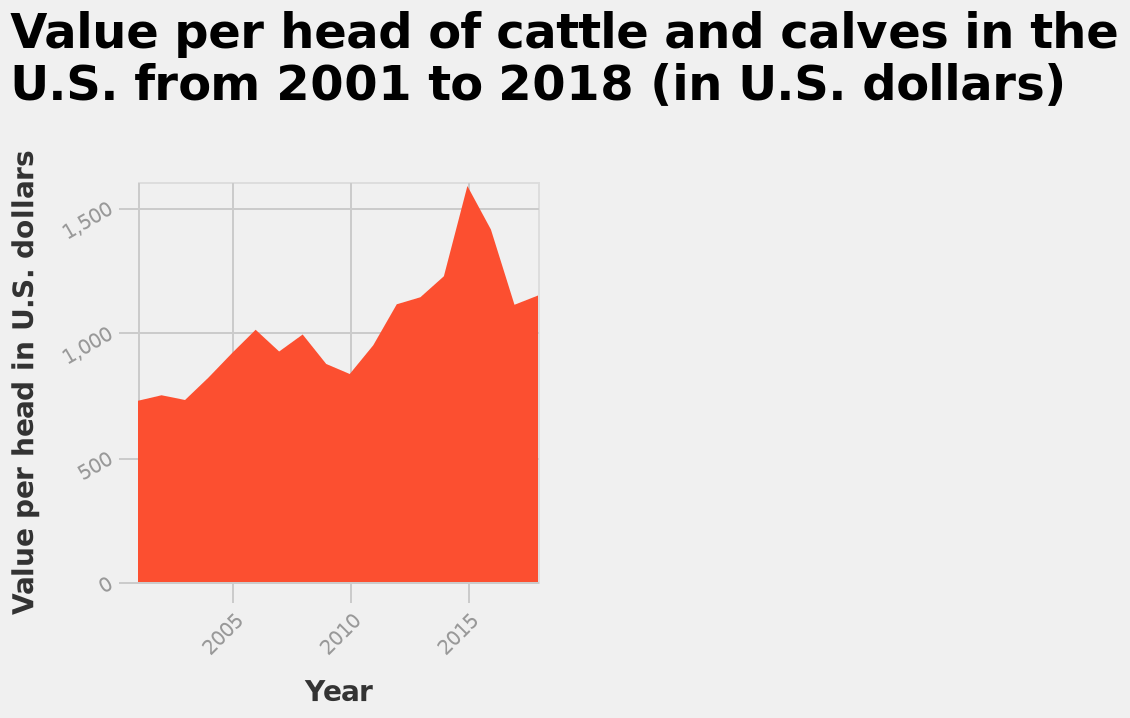<image>
What is the title of the area diagram?  The title of the area diagram is "Value per head of cattle and calves in the U.S. from 2001 to 2018 (in U.S. dollars)." How did the value per head of cattle and calves change from 2000 to around 2005? The value per head of cattle and calves stayed quite stable from 2000 for a few years and then sharply increased in 2005 to almost double the price. Offer a thorough analysis of the image. The value per head of cattle and calves stayed quite stable from 2000 for a few years. The value per head of cattle and calves sharply increased in 2005 to almost double the price but then fell in the next five years. After 2010 the value per head of cattle and calves once again rose sharply and for around five years, the price was almost treble what it was originally. After 2015 the value per head of cattle and calves has declined but looks to show signs of recovery and increase again. When did the value per head of cattle and calves start declining?  The value per head of cattle and calves started declining after 2015. Did the value per head of cattle and calves show signs of recovery after declining? Yes, the value per head of cattle and calves looks to show signs of recovery and increase again after 2015. 